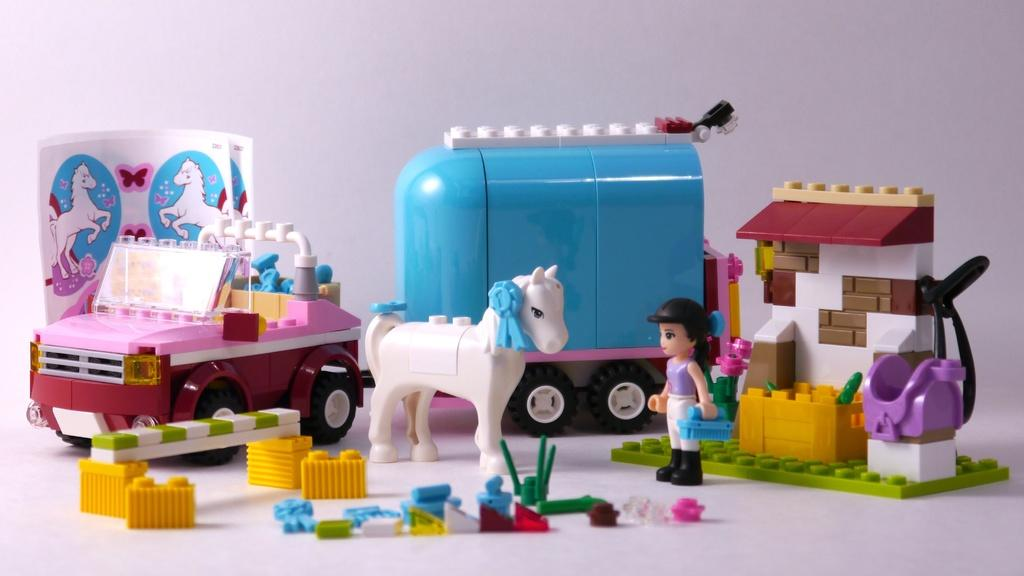What type of objects can be seen on the white surface in the image? There are toys and stickers on the white surface in the image. What color is the background of the image? The background of the image is white. Can you describe the surface where the toys and stickers are placed? The toys and stickers are on a white surface. What type of cheese is being washed in the image? There is no cheese or washing activity present in the image. 